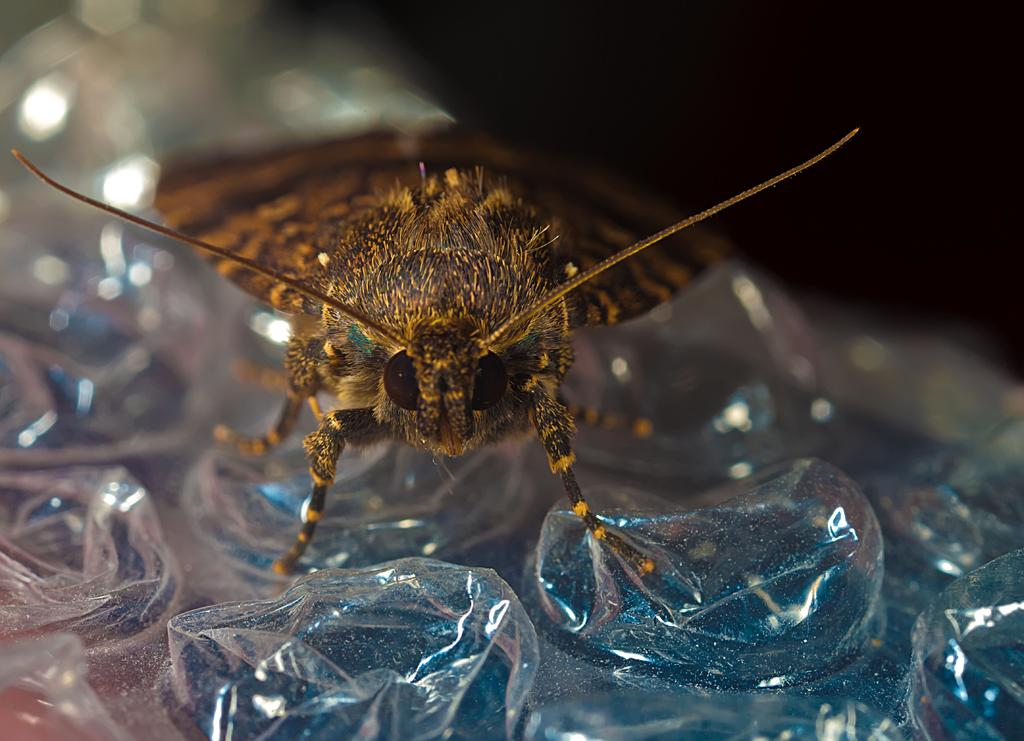What type of creature is present in the image? There is an insect in the image. Where is the insect located? The insect is on a cover. What can be observed about the overall lighting in the image? The background of the image is dark. What letter can be seen on the insect's back in the image? There is no letter visible on the insect's back in the image. How many toes does the insect have in the image? Insects do not have toes, so this question cannot be answered. 